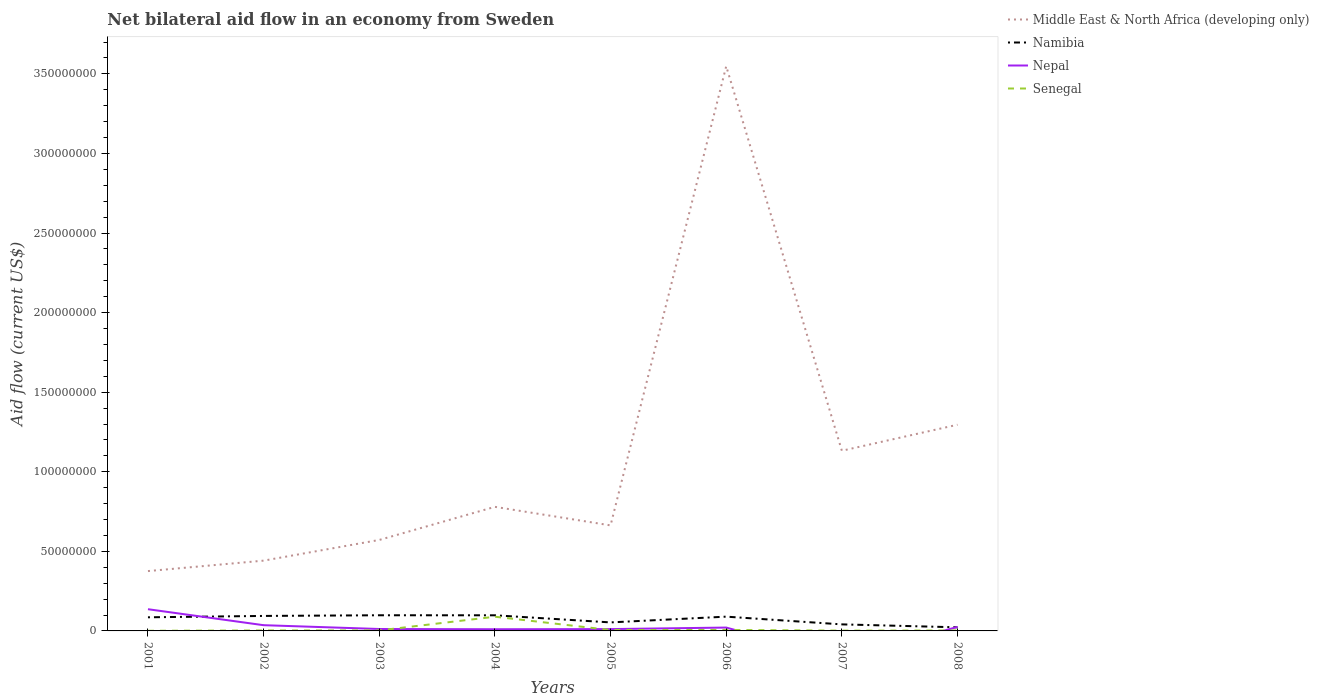How many different coloured lines are there?
Offer a very short reply. 4. Does the line corresponding to Senegal intersect with the line corresponding to Namibia?
Your response must be concise. No. Across all years, what is the maximum net bilateral aid flow in Namibia?
Offer a very short reply. 2.27e+06. What is the total net bilateral aid flow in Namibia in the graph?
Provide a short and direct response. 7.55e+06. What is the difference between the highest and the second highest net bilateral aid flow in Namibia?
Give a very brief answer. 7.57e+06. What is the difference between the highest and the lowest net bilateral aid flow in Middle East & North Africa (developing only)?
Provide a succinct answer. 3. How many years are there in the graph?
Your answer should be compact. 8. What is the difference between two consecutive major ticks on the Y-axis?
Your answer should be compact. 5.00e+07. Are the values on the major ticks of Y-axis written in scientific E-notation?
Your answer should be compact. No. Does the graph contain grids?
Provide a short and direct response. No. Where does the legend appear in the graph?
Give a very brief answer. Top right. How are the legend labels stacked?
Provide a succinct answer. Vertical. What is the title of the graph?
Ensure brevity in your answer.  Net bilateral aid flow in an economy from Sweden. Does "Sub-Saharan Africa (all income levels)" appear as one of the legend labels in the graph?
Your answer should be very brief. No. What is the label or title of the X-axis?
Your answer should be very brief. Years. What is the label or title of the Y-axis?
Offer a terse response. Aid flow (current US$). What is the Aid flow (current US$) of Middle East & North Africa (developing only) in 2001?
Offer a terse response. 3.76e+07. What is the Aid flow (current US$) of Namibia in 2001?
Your answer should be very brief. 8.56e+06. What is the Aid flow (current US$) of Nepal in 2001?
Your answer should be very brief. 1.36e+07. What is the Aid flow (current US$) of Middle East & North Africa (developing only) in 2002?
Offer a terse response. 4.42e+07. What is the Aid flow (current US$) in Namibia in 2002?
Make the answer very short. 9.42e+06. What is the Aid flow (current US$) in Nepal in 2002?
Your response must be concise. 3.60e+06. What is the Aid flow (current US$) of Middle East & North Africa (developing only) in 2003?
Provide a short and direct response. 5.72e+07. What is the Aid flow (current US$) of Namibia in 2003?
Your answer should be very brief. 9.84e+06. What is the Aid flow (current US$) in Nepal in 2003?
Your answer should be compact. 1.21e+06. What is the Aid flow (current US$) of Middle East & North Africa (developing only) in 2004?
Provide a short and direct response. 7.80e+07. What is the Aid flow (current US$) in Namibia in 2004?
Ensure brevity in your answer.  9.82e+06. What is the Aid flow (current US$) of Nepal in 2004?
Ensure brevity in your answer.  1.05e+06. What is the Aid flow (current US$) of Senegal in 2004?
Keep it short and to the point. 8.93e+06. What is the Aid flow (current US$) of Middle East & North Africa (developing only) in 2005?
Your answer should be compact. 6.63e+07. What is the Aid flow (current US$) of Namibia in 2005?
Offer a very short reply. 5.35e+06. What is the Aid flow (current US$) in Nepal in 2005?
Make the answer very short. 1.15e+06. What is the Aid flow (current US$) in Senegal in 2005?
Keep it short and to the point. 5.60e+05. What is the Aid flow (current US$) in Middle East & North Africa (developing only) in 2006?
Your answer should be very brief. 3.55e+08. What is the Aid flow (current US$) of Namibia in 2006?
Give a very brief answer. 8.97e+06. What is the Aid flow (current US$) of Nepal in 2006?
Provide a succinct answer. 2.11e+06. What is the Aid flow (current US$) of Senegal in 2006?
Provide a succinct answer. 6.20e+05. What is the Aid flow (current US$) in Middle East & North Africa (developing only) in 2007?
Provide a succinct answer. 1.13e+08. What is the Aid flow (current US$) in Namibia in 2007?
Give a very brief answer. 4.11e+06. What is the Aid flow (current US$) of Nepal in 2007?
Your response must be concise. 0. What is the Aid flow (current US$) in Senegal in 2007?
Offer a terse response. 1.90e+05. What is the Aid flow (current US$) in Middle East & North Africa (developing only) in 2008?
Your response must be concise. 1.30e+08. What is the Aid flow (current US$) in Namibia in 2008?
Make the answer very short. 2.27e+06. What is the Aid flow (current US$) of Nepal in 2008?
Your response must be concise. 2.53e+06. What is the Aid flow (current US$) in Senegal in 2008?
Your answer should be compact. 2.90e+05. Across all years, what is the maximum Aid flow (current US$) of Middle East & North Africa (developing only)?
Offer a very short reply. 3.55e+08. Across all years, what is the maximum Aid flow (current US$) of Namibia?
Provide a succinct answer. 9.84e+06. Across all years, what is the maximum Aid flow (current US$) in Nepal?
Give a very brief answer. 1.36e+07. Across all years, what is the maximum Aid flow (current US$) of Senegal?
Provide a short and direct response. 8.93e+06. Across all years, what is the minimum Aid flow (current US$) in Middle East & North Africa (developing only)?
Make the answer very short. 3.76e+07. Across all years, what is the minimum Aid flow (current US$) of Namibia?
Provide a succinct answer. 2.27e+06. Across all years, what is the minimum Aid flow (current US$) in Nepal?
Keep it short and to the point. 0. Across all years, what is the minimum Aid flow (current US$) in Senegal?
Offer a very short reply. 9.00e+04. What is the total Aid flow (current US$) in Middle East & North Africa (developing only) in the graph?
Ensure brevity in your answer.  8.81e+08. What is the total Aid flow (current US$) in Namibia in the graph?
Provide a succinct answer. 5.83e+07. What is the total Aid flow (current US$) in Nepal in the graph?
Provide a succinct answer. 2.53e+07. What is the total Aid flow (current US$) in Senegal in the graph?
Provide a short and direct response. 1.13e+07. What is the difference between the Aid flow (current US$) of Middle East & North Africa (developing only) in 2001 and that in 2002?
Your answer should be very brief. -6.56e+06. What is the difference between the Aid flow (current US$) in Namibia in 2001 and that in 2002?
Keep it short and to the point. -8.60e+05. What is the difference between the Aid flow (current US$) in Nepal in 2001 and that in 2002?
Give a very brief answer. 1.00e+07. What is the difference between the Aid flow (current US$) of Senegal in 2001 and that in 2002?
Keep it short and to the point. -2.00e+05. What is the difference between the Aid flow (current US$) in Middle East & North Africa (developing only) in 2001 and that in 2003?
Offer a very short reply. -1.96e+07. What is the difference between the Aid flow (current US$) in Namibia in 2001 and that in 2003?
Offer a terse response. -1.28e+06. What is the difference between the Aid flow (current US$) in Nepal in 2001 and that in 2003?
Ensure brevity in your answer.  1.24e+07. What is the difference between the Aid flow (current US$) of Senegal in 2001 and that in 2003?
Offer a very short reply. -2.20e+05. What is the difference between the Aid flow (current US$) of Middle East & North Africa (developing only) in 2001 and that in 2004?
Provide a short and direct response. -4.04e+07. What is the difference between the Aid flow (current US$) in Namibia in 2001 and that in 2004?
Keep it short and to the point. -1.26e+06. What is the difference between the Aid flow (current US$) of Nepal in 2001 and that in 2004?
Offer a very short reply. 1.26e+07. What is the difference between the Aid flow (current US$) in Senegal in 2001 and that in 2004?
Give a very brief answer. -8.84e+06. What is the difference between the Aid flow (current US$) in Middle East & North Africa (developing only) in 2001 and that in 2005?
Ensure brevity in your answer.  -2.87e+07. What is the difference between the Aid flow (current US$) in Namibia in 2001 and that in 2005?
Offer a terse response. 3.21e+06. What is the difference between the Aid flow (current US$) of Nepal in 2001 and that in 2005?
Your answer should be compact. 1.25e+07. What is the difference between the Aid flow (current US$) in Senegal in 2001 and that in 2005?
Offer a very short reply. -4.70e+05. What is the difference between the Aid flow (current US$) of Middle East & North Africa (developing only) in 2001 and that in 2006?
Make the answer very short. -3.17e+08. What is the difference between the Aid flow (current US$) of Namibia in 2001 and that in 2006?
Your response must be concise. -4.10e+05. What is the difference between the Aid flow (current US$) of Nepal in 2001 and that in 2006?
Offer a terse response. 1.15e+07. What is the difference between the Aid flow (current US$) of Senegal in 2001 and that in 2006?
Ensure brevity in your answer.  -5.30e+05. What is the difference between the Aid flow (current US$) of Middle East & North Africa (developing only) in 2001 and that in 2007?
Give a very brief answer. -7.56e+07. What is the difference between the Aid flow (current US$) in Namibia in 2001 and that in 2007?
Your answer should be compact. 4.45e+06. What is the difference between the Aid flow (current US$) of Senegal in 2001 and that in 2007?
Keep it short and to the point. -1.00e+05. What is the difference between the Aid flow (current US$) in Middle East & North Africa (developing only) in 2001 and that in 2008?
Ensure brevity in your answer.  -9.20e+07. What is the difference between the Aid flow (current US$) in Namibia in 2001 and that in 2008?
Your response must be concise. 6.29e+06. What is the difference between the Aid flow (current US$) in Nepal in 2001 and that in 2008?
Give a very brief answer. 1.11e+07. What is the difference between the Aid flow (current US$) in Senegal in 2001 and that in 2008?
Your answer should be compact. -2.00e+05. What is the difference between the Aid flow (current US$) of Middle East & North Africa (developing only) in 2002 and that in 2003?
Offer a very short reply. -1.30e+07. What is the difference between the Aid flow (current US$) in Namibia in 2002 and that in 2003?
Offer a terse response. -4.20e+05. What is the difference between the Aid flow (current US$) of Nepal in 2002 and that in 2003?
Keep it short and to the point. 2.39e+06. What is the difference between the Aid flow (current US$) in Senegal in 2002 and that in 2003?
Keep it short and to the point. -2.00e+04. What is the difference between the Aid flow (current US$) of Middle East & North Africa (developing only) in 2002 and that in 2004?
Your answer should be very brief. -3.38e+07. What is the difference between the Aid flow (current US$) of Namibia in 2002 and that in 2004?
Ensure brevity in your answer.  -4.00e+05. What is the difference between the Aid flow (current US$) in Nepal in 2002 and that in 2004?
Offer a terse response. 2.55e+06. What is the difference between the Aid flow (current US$) in Senegal in 2002 and that in 2004?
Provide a succinct answer. -8.64e+06. What is the difference between the Aid flow (current US$) in Middle East & North Africa (developing only) in 2002 and that in 2005?
Your answer should be compact. -2.22e+07. What is the difference between the Aid flow (current US$) of Namibia in 2002 and that in 2005?
Give a very brief answer. 4.07e+06. What is the difference between the Aid flow (current US$) of Nepal in 2002 and that in 2005?
Keep it short and to the point. 2.45e+06. What is the difference between the Aid flow (current US$) in Senegal in 2002 and that in 2005?
Offer a very short reply. -2.70e+05. What is the difference between the Aid flow (current US$) of Middle East & North Africa (developing only) in 2002 and that in 2006?
Offer a terse response. -3.11e+08. What is the difference between the Aid flow (current US$) of Nepal in 2002 and that in 2006?
Your answer should be very brief. 1.49e+06. What is the difference between the Aid flow (current US$) of Senegal in 2002 and that in 2006?
Keep it short and to the point. -3.30e+05. What is the difference between the Aid flow (current US$) in Middle East & North Africa (developing only) in 2002 and that in 2007?
Your response must be concise. -6.90e+07. What is the difference between the Aid flow (current US$) of Namibia in 2002 and that in 2007?
Ensure brevity in your answer.  5.31e+06. What is the difference between the Aid flow (current US$) in Middle East & North Africa (developing only) in 2002 and that in 2008?
Make the answer very short. -8.54e+07. What is the difference between the Aid flow (current US$) in Namibia in 2002 and that in 2008?
Keep it short and to the point. 7.15e+06. What is the difference between the Aid flow (current US$) in Nepal in 2002 and that in 2008?
Offer a terse response. 1.07e+06. What is the difference between the Aid flow (current US$) in Senegal in 2002 and that in 2008?
Provide a succinct answer. 0. What is the difference between the Aid flow (current US$) of Middle East & North Africa (developing only) in 2003 and that in 2004?
Provide a short and direct response. -2.08e+07. What is the difference between the Aid flow (current US$) of Senegal in 2003 and that in 2004?
Your response must be concise. -8.62e+06. What is the difference between the Aid flow (current US$) in Middle East & North Africa (developing only) in 2003 and that in 2005?
Your answer should be very brief. -9.15e+06. What is the difference between the Aid flow (current US$) of Namibia in 2003 and that in 2005?
Make the answer very short. 4.49e+06. What is the difference between the Aid flow (current US$) in Nepal in 2003 and that in 2005?
Your response must be concise. 6.00e+04. What is the difference between the Aid flow (current US$) of Middle East & North Africa (developing only) in 2003 and that in 2006?
Give a very brief answer. -2.98e+08. What is the difference between the Aid flow (current US$) of Namibia in 2003 and that in 2006?
Give a very brief answer. 8.70e+05. What is the difference between the Aid flow (current US$) of Nepal in 2003 and that in 2006?
Your answer should be very brief. -9.00e+05. What is the difference between the Aid flow (current US$) of Senegal in 2003 and that in 2006?
Offer a terse response. -3.10e+05. What is the difference between the Aid flow (current US$) in Middle East & North Africa (developing only) in 2003 and that in 2007?
Offer a very short reply. -5.60e+07. What is the difference between the Aid flow (current US$) of Namibia in 2003 and that in 2007?
Make the answer very short. 5.73e+06. What is the difference between the Aid flow (current US$) of Senegal in 2003 and that in 2007?
Offer a very short reply. 1.20e+05. What is the difference between the Aid flow (current US$) in Middle East & North Africa (developing only) in 2003 and that in 2008?
Provide a short and direct response. -7.24e+07. What is the difference between the Aid flow (current US$) in Namibia in 2003 and that in 2008?
Give a very brief answer. 7.57e+06. What is the difference between the Aid flow (current US$) of Nepal in 2003 and that in 2008?
Your answer should be compact. -1.32e+06. What is the difference between the Aid flow (current US$) of Middle East & North Africa (developing only) in 2004 and that in 2005?
Ensure brevity in your answer.  1.16e+07. What is the difference between the Aid flow (current US$) in Namibia in 2004 and that in 2005?
Give a very brief answer. 4.47e+06. What is the difference between the Aid flow (current US$) in Nepal in 2004 and that in 2005?
Your response must be concise. -1.00e+05. What is the difference between the Aid flow (current US$) of Senegal in 2004 and that in 2005?
Offer a terse response. 8.37e+06. What is the difference between the Aid flow (current US$) of Middle East & North Africa (developing only) in 2004 and that in 2006?
Your answer should be very brief. -2.77e+08. What is the difference between the Aid flow (current US$) of Namibia in 2004 and that in 2006?
Offer a very short reply. 8.50e+05. What is the difference between the Aid flow (current US$) of Nepal in 2004 and that in 2006?
Make the answer very short. -1.06e+06. What is the difference between the Aid flow (current US$) of Senegal in 2004 and that in 2006?
Ensure brevity in your answer.  8.31e+06. What is the difference between the Aid flow (current US$) of Middle East & North Africa (developing only) in 2004 and that in 2007?
Your response must be concise. -3.52e+07. What is the difference between the Aid flow (current US$) of Namibia in 2004 and that in 2007?
Offer a very short reply. 5.71e+06. What is the difference between the Aid flow (current US$) of Senegal in 2004 and that in 2007?
Make the answer very short. 8.74e+06. What is the difference between the Aid flow (current US$) of Middle East & North Africa (developing only) in 2004 and that in 2008?
Your answer should be compact. -5.16e+07. What is the difference between the Aid flow (current US$) in Namibia in 2004 and that in 2008?
Ensure brevity in your answer.  7.55e+06. What is the difference between the Aid flow (current US$) of Nepal in 2004 and that in 2008?
Your response must be concise. -1.48e+06. What is the difference between the Aid flow (current US$) of Senegal in 2004 and that in 2008?
Offer a very short reply. 8.64e+06. What is the difference between the Aid flow (current US$) in Middle East & North Africa (developing only) in 2005 and that in 2006?
Your response must be concise. -2.88e+08. What is the difference between the Aid flow (current US$) in Namibia in 2005 and that in 2006?
Your answer should be very brief. -3.62e+06. What is the difference between the Aid flow (current US$) in Nepal in 2005 and that in 2006?
Keep it short and to the point. -9.60e+05. What is the difference between the Aid flow (current US$) in Middle East & North Africa (developing only) in 2005 and that in 2007?
Your response must be concise. -4.69e+07. What is the difference between the Aid flow (current US$) in Namibia in 2005 and that in 2007?
Offer a very short reply. 1.24e+06. What is the difference between the Aid flow (current US$) in Senegal in 2005 and that in 2007?
Make the answer very short. 3.70e+05. What is the difference between the Aid flow (current US$) in Middle East & North Africa (developing only) in 2005 and that in 2008?
Keep it short and to the point. -6.32e+07. What is the difference between the Aid flow (current US$) of Namibia in 2005 and that in 2008?
Provide a short and direct response. 3.08e+06. What is the difference between the Aid flow (current US$) of Nepal in 2005 and that in 2008?
Provide a succinct answer. -1.38e+06. What is the difference between the Aid flow (current US$) of Middle East & North Africa (developing only) in 2006 and that in 2007?
Your response must be concise. 2.42e+08. What is the difference between the Aid flow (current US$) of Namibia in 2006 and that in 2007?
Keep it short and to the point. 4.86e+06. What is the difference between the Aid flow (current US$) in Senegal in 2006 and that in 2007?
Provide a succinct answer. 4.30e+05. What is the difference between the Aid flow (current US$) of Middle East & North Africa (developing only) in 2006 and that in 2008?
Provide a short and direct response. 2.25e+08. What is the difference between the Aid flow (current US$) in Namibia in 2006 and that in 2008?
Offer a very short reply. 6.70e+06. What is the difference between the Aid flow (current US$) of Nepal in 2006 and that in 2008?
Give a very brief answer. -4.20e+05. What is the difference between the Aid flow (current US$) of Middle East & North Africa (developing only) in 2007 and that in 2008?
Provide a succinct answer. -1.63e+07. What is the difference between the Aid flow (current US$) of Namibia in 2007 and that in 2008?
Offer a terse response. 1.84e+06. What is the difference between the Aid flow (current US$) of Senegal in 2007 and that in 2008?
Your answer should be very brief. -1.00e+05. What is the difference between the Aid flow (current US$) of Middle East & North Africa (developing only) in 2001 and the Aid flow (current US$) of Namibia in 2002?
Keep it short and to the point. 2.82e+07. What is the difference between the Aid flow (current US$) in Middle East & North Africa (developing only) in 2001 and the Aid flow (current US$) in Nepal in 2002?
Your answer should be compact. 3.40e+07. What is the difference between the Aid flow (current US$) of Middle East & North Africa (developing only) in 2001 and the Aid flow (current US$) of Senegal in 2002?
Your answer should be very brief. 3.73e+07. What is the difference between the Aid flow (current US$) in Namibia in 2001 and the Aid flow (current US$) in Nepal in 2002?
Offer a terse response. 4.96e+06. What is the difference between the Aid flow (current US$) in Namibia in 2001 and the Aid flow (current US$) in Senegal in 2002?
Your response must be concise. 8.27e+06. What is the difference between the Aid flow (current US$) in Nepal in 2001 and the Aid flow (current US$) in Senegal in 2002?
Your answer should be compact. 1.34e+07. What is the difference between the Aid flow (current US$) in Middle East & North Africa (developing only) in 2001 and the Aid flow (current US$) in Namibia in 2003?
Your answer should be very brief. 2.78e+07. What is the difference between the Aid flow (current US$) in Middle East & North Africa (developing only) in 2001 and the Aid flow (current US$) in Nepal in 2003?
Your answer should be very brief. 3.64e+07. What is the difference between the Aid flow (current US$) in Middle East & North Africa (developing only) in 2001 and the Aid flow (current US$) in Senegal in 2003?
Give a very brief answer. 3.73e+07. What is the difference between the Aid flow (current US$) in Namibia in 2001 and the Aid flow (current US$) in Nepal in 2003?
Your answer should be compact. 7.35e+06. What is the difference between the Aid flow (current US$) of Namibia in 2001 and the Aid flow (current US$) of Senegal in 2003?
Your answer should be compact. 8.25e+06. What is the difference between the Aid flow (current US$) in Nepal in 2001 and the Aid flow (current US$) in Senegal in 2003?
Provide a short and direct response. 1.33e+07. What is the difference between the Aid flow (current US$) in Middle East & North Africa (developing only) in 2001 and the Aid flow (current US$) in Namibia in 2004?
Give a very brief answer. 2.78e+07. What is the difference between the Aid flow (current US$) of Middle East & North Africa (developing only) in 2001 and the Aid flow (current US$) of Nepal in 2004?
Offer a terse response. 3.66e+07. What is the difference between the Aid flow (current US$) of Middle East & North Africa (developing only) in 2001 and the Aid flow (current US$) of Senegal in 2004?
Your response must be concise. 2.87e+07. What is the difference between the Aid flow (current US$) of Namibia in 2001 and the Aid flow (current US$) of Nepal in 2004?
Offer a terse response. 7.51e+06. What is the difference between the Aid flow (current US$) of Namibia in 2001 and the Aid flow (current US$) of Senegal in 2004?
Your answer should be compact. -3.70e+05. What is the difference between the Aid flow (current US$) of Nepal in 2001 and the Aid flow (current US$) of Senegal in 2004?
Keep it short and to the point. 4.71e+06. What is the difference between the Aid flow (current US$) in Middle East & North Africa (developing only) in 2001 and the Aid flow (current US$) in Namibia in 2005?
Provide a succinct answer. 3.22e+07. What is the difference between the Aid flow (current US$) in Middle East & North Africa (developing only) in 2001 and the Aid flow (current US$) in Nepal in 2005?
Offer a terse response. 3.64e+07. What is the difference between the Aid flow (current US$) of Middle East & North Africa (developing only) in 2001 and the Aid flow (current US$) of Senegal in 2005?
Offer a very short reply. 3.70e+07. What is the difference between the Aid flow (current US$) of Namibia in 2001 and the Aid flow (current US$) of Nepal in 2005?
Ensure brevity in your answer.  7.41e+06. What is the difference between the Aid flow (current US$) of Nepal in 2001 and the Aid flow (current US$) of Senegal in 2005?
Offer a terse response. 1.31e+07. What is the difference between the Aid flow (current US$) in Middle East & North Africa (developing only) in 2001 and the Aid flow (current US$) in Namibia in 2006?
Your answer should be compact. 2.86e+07. What is the difference between the Aid flow (current US$) in Middle East & North Africa (developing only) in 2001 and the Aid flow (current US$) in Nepal in 2006?
Keep it short and to the point. 3.55e+07. What is the difference between the Aid flow (current US$) of Middle East & North Africa (developing only) in 2001 and the Aid flow (current US$) of Senegal in 2006?
Keep it short and to the point. 3.70e+07. What is the difference between the Aid flow (current US$) of Namibia in 2001 and the Aid flow (current US$) of Nepal in 2006?
Provide a succinct answer. 6.45e+06. What is the difference between the Aid flow (current US$) of Namibia in 2001 and the Aid flow (current US$) of Senegal in 2006?
Your response must be concise. 7.94e+06. What is the difference between the Aid flow (current US$) in Nepal in 2001 and the Aid flow (current US$) in Senegal in 2006?
Keep it short and to the point. 1.30e+07. What is the difference between the Aid flow (current US$) of Middle East & North Africa (developing only) in 2001 and the Aid flow (current US$) of Namibia in 2007?
Keep it short and to the point. 3.35e+07. What is the difference between the Aid flow (current US$) of Middle East & North Africa (developing only) in 2001 and the Aid flow (current US$) of Senegal in 2007?
Offer a very short reply. 3.74e+07. What is the difference between the Aid flow (current US$) in Namibia in 2001 and the Aid flow (current US$) in Senegal in 2007?
Keep it short and to the point. 8.37e+06. What is the difference between the Aid flow (current US$) in Nepal in 2001 and the Aid flow (current US$) in Senegal in 2007?
Your response must be concise. 1.34e+07. What is the difference between the Aid flow (current US$) of Middle East & North Africa (developing only) in 2001 and the Aid flow (current US$) of Namibia in 2008?
Provide a short and direct response. 3.53e+07. What is the difference between the Aid flow (current US$) of Middle East & North Africa (developing only) in 2001 and the Aid flow (current US$) of Nepal in 2008?
Give a very brief answer. 3.51e+07. What is the difference between the Aid flow (current US$) in Middle East & North Africa (developing only) in 2001 and the Aid flow (current US$) in Senegal in 2008?
Provide a short and direct response. 3.73e+07. What is the difference between the Aid flow (current US$) in Namibia in 2001 and the Aid flow (current US$) in Nepal in 2008?
Ensure brevity in your answer.  6.03e+06. What is the difference between the Aid flow (current US$) of Namibia in 2001 and the Aid flow (current US$) of Senegal in 2008?
Your answer should be compact. 8.27e+06. What is the difference between the Aid flow (current US$) in Nepal in 2001 and the Aid flow (current US$) in Senegal in 2008?
Make the answer very short. 1.34e+07. What is the difference between the Aid flow (current US$) in Middle East & North Africa (developing only) in 2002 and the Aid flow (current US$) in Namibia in 2003?
Provide a succinct answer. 3.43e+07. What is the difference between the Aid flow (current US$) in Middle East & North Africa (developing only) in 2002 and the Aid flow (current US$) in Nepal in 2003?
Make the answer very short. 4.30e+07. What is the difference between the Aid flow (current US$) of Middle East & North Africa (developing only) in 2002 and the Aid flow (current US$) of Senegal in 2003?
Your response must be concise. 4.38e+07. What is the difference between the Aid flow (current US$) of Namibia in 2002 and the Aid flow (current US$) of Nepal in 2003?
Offer a terse response. 8.21e+06. What is the difference between the Aid flow (current US$) in Namibia in 2002 and the Aid flow (current US$) in Senegal in 2003?
Give a very brief answer. 9.11e+06. What is the difference between the Aid flow (current US$) in Nepal in 2002 and the Aid flow (current US$) in Senegal in 2003?
Offer a very short reply. 3.29e+06. What is the difference between the Aid flow (current US$) in Middle East & North Africa (developing only) in 2002 and the Aid flow (current US$) in Namibia in 2004?
Ensure brevity in your answer.  3.43e+07. What is the difference between the Aid flow (current US$) of Middle East & North Africa (developing only) in 2002 and the Aid flow (current US$) of Nepal in 2004?
Provide a succinct answer. 4.31e+07. What is the difference between the Aid flow (current US$) in Middle East & North Africa (developing only) in 2002 and the Aid flow (current US$) in Senegal in 2004?
Provide a succinct answer. 3.52e+07. What is the difference between the Aid flow (current US$) of Namibia in 2002 and the Aid flow (current US$) of Nepal in 2004?
Ensure brevity in your answer.  8.37e+06. What is the difference between the Aid flow (current US$) of Namibia in 2002 and the Aid flow (current US$) of Senegal in 2004?
Your answer should be compact. 4.90e+05. What is the difference between the Aid flow (current US$) of Nepal in 2002 and the Aid flow (current US$) of Senegal in 2004?
Keep it short and to the point. -5.33e+06. What is the difference between the Aid flow (current US$) of Middle East & North Africa (developing only) in 2002 and the Aid flow (current US$) of Namibia in 2005?
Ensure brevity in your answer.  3.88e+07. What is the difference between the Aid flow (current US$) of Middle East & North Africa (developing only) in 2002 and the Aid flow (current US$) of Nepal in 2005?
Your answer should be very brief. 4.30e+07. What is the difference between the Aid flow (current US$) of Middle East & North Africa (developing only) in 2002 and the Aid flow (current US$) of Senegal in 2005?
Give a very brief answer. 4.36e+07. What is the difference between the Aid flow (current US$) of Namibia in 2002 and the Aid flow (current US$) of Nepal in 2005?
Offer a terse response. 8.27e+06. What is the difference between the Aid flow (current US$) of Namibia in 2002 and the Aid flow (current US$) of Senegal in 2005?
Keep it short and to the point. 8.86e+06. What is the difference between the Aid flow (current US$) in Nepal in 2002 and the Aid flow (current US$) in Senegal in 2005?
Your answer should be very brief. 3.04e+06. What is the difference between the Aid flow (current US$) in Middle East & North Africa (developing only) in 2002 and the Aid flow (current US$) in Namibia in 2006?
Make the answer very short. 3.52e+07. What is the difference between the Aid flow (current US$) of Middle East & North Africa (developing only) in 2002 and the Aid flow (current US$) of Nepal in 2006?
Your answer should be compact. 4.20e+07. What is the difference between the Aid flow (current US$) of Middle East & North Africa (developing only) in 2002 and the Aid flow (current US$) of Senegal in 2006?
Your response must be concise. 4.35e+07. What is the difference between the Aid flow (current US$) in Namibia in 2002 and the Aid flow (current US$) in Nepal in 2006?
Keep it short and to the point. 7.31e+06. What is the difference between the Aid flow (current US$) of Namibia in 2002 and the Aid flow (current US$) of Senegal in 2006?
Keep it short and to the point. 8.80e+06. What is the difference between the Aid flow (current US$) of Nepal in 2002 and the Aid flow (current US$) of Senegal in 2006?
Offer a very short reply. 2.98e+06. What is the difference between the Aid flow (current US$) in Middle East & North Africa (developing only) in 2002 and the Aid flow (current US$) in Namibia in 2007?
Make the answer very short. 4.00e+07. What is the difference between the Aid flow (current US$) of Middle East & North Africa (developing only) in 2002 and the Aid flow (current US$) of Senegal in 2007?
Ensure brevity in your answer.  4.40e+07. What is the difference between the Aid flow (current US$) in Namibia in 2002 and the Aid flow (current US$) in Senegal in 2007?
Your answer should be compact. 9.23e+06. What is the difference between the Aid flow (current US$) in Nepal in 2002 and the Aid flow (current US$) in Senegal in 2007?
Provide a short and direct response. 3.41e+06. What is the difference between the Aid flow (current US$) in Middle East & North Africa (developing only) in 2002 and the Aid flow (current US$) in Namibia in 2008?
Your answer should be very brief. 4.19e+07. What is the difference between the Aid flow (current US$) in Middle East & North Africa (developing only) in 2002 and the Aid flow (current US$) in Nepal in 2008?
Keep it short and to the point. 4.16e+07. What is the difference between the Aid flow (current US$) in Middle East & North Africa (developing only) in 2002 and the Aid flow (current US$) in Senegal in 2008?
Keep it short and to the point. 4.39e+07. What is the difference between the Aid flow (current US$) of Namibia in 2002 and the Aid flow (current US$) of Nepal in 2008?
Provide a succinct answer. 6.89e+06. What is the difference between the Aid flow (current US$) of Namibia in 2002 and the Aid flow (current US$) of Senegal in 2008?
Provide a short and direct response. 9.13e+06. What is the difference between the Aid flow (current US$) of Nepal in 2002 and the Aid flow (current US$) of Senegal in 2008?
Your response must be concise. 3.31e+06. What is the difference between the Aid flow (current US$) of Middle East & North Africa (developing only) in 2003 and the Aid flow (current US$) of Namibia in 2004?
Keep it short and to the point. 4.73e+07. What is the difference between the Aid flow (current US$) in Middle East & North Africa (developing only) in 2003 and the Aid flow (current US$) in Nepal in 2004?
Ensure brevity in your answer.  5.61e+07. What is the difference between the Aid flow (current US$) in Middle East & North Africa (developing only) in 2003 and the Aid flow (current US$) in Senegal in 2004?
Keep it short and to the point. 4.82e+07. What is the difference between the Aid flow (current US$) of Namibia in 2003 and the Aid flow (current US$) of Nepal in 2004?
Provide a succinct answer. 8.79e+06. What is the difference between the Aid flow (current US$) of Namibia in 2003 and the Aid flow (current US$) of Senegal in 2004?
Offer a terse response. 9.10e+05. What is the difference between the Aid flow (current US$) of Nepal in 2003 and the Aid flow (current US$) of Senegal in 2004?
Provide a succinct answer. -7.72e+06. What is the difference between the Aid flow (current US$) of Middle East & North Africa (developing only) in 2003 and the Aid flow (current US$) of Namibia in 2005?
Your response must be concise. 5.18e+07. What is the difference between the Aid flow (current US$) in Middle East & North Africa (developing only) in 2003 and the Aid flow (current US$) in Nepal in 2005?
Your response must be concise. 5.60e+07. What is the difference between the Aid flow (current US$) of Middle East & North Africa (developing only) in 2003 and the Aid flow (current US$) of Senegal in 2005?
Your answer should be very brief. 5.66e+07. What is the difference between the Aid flow (current US$) of Namibia in 2003 and the Aid flow (current US$) of Nepal in 2005?
Your answer should be compact. 8.69e+06. What is the difference between the Aid flow (current US$) in Namibia in 2003 and the Aid flow (current US$) in Senegal in 2005?
Provide a short and direct response. 9.28e+06. What is the difference between the Aid flow (current US$) in Nepal in 2003 and the Aid flow (current US$) in Senegal in 2005?
Provide a short and direct response. 6.50e+05. What is the difference between the Aid flow (current US$) in Middle East & North Africa (developing only) in 2003 and the Aid flow (current US$) in Namibia in 2006?
Provide a short and direct response. 4.82e+07. What is the difference between the Aid flow (current US$) in Middle East & North Africa (developing only) in 2003 and the Aid flow (current US$) in Nepal in 2006?
Ensure brevity in your answer.  5.50e+07. What is the difference between the Aid flow (current US$) in Middle East & North Africa (developing only) in 2003 and the Aid flow (current US$) in Senegal in 2006?
Your answer should be very brief. 5.65e+07. What is the difference between the Aid flow (current US$) in Namibia in 2003 and the Aid flow (current US$) in Nepal in 2006?
Your answer should be compact. 7.73e+06. What is the difference between the Aid flow (current US$) in Namibia in 2003 and the Aid flow (current US$) in Senegal in 2006?
Your response must be concise. 9.22e+06. What is the difference between the Aid flow (current US$) in Nepal in 2003 and the Aid flow (current US$) in Senegal in 2006?
Make the answer very short. 5.90e+05. What is the difference between the Aid flow (current US$) in Middle East & North Africa (developing only) in 2003 and the Aid flow (current US$) in Namibia in 2007?
Your response must be concise. 5.30e+07. What is the difference between the Aid flow (current US$) of Middle East & North Africa (developing only) in 2003 and the Aid flow (current US$) of Senegal in 2007?
Your answer should be compact. 5.70e+07. What is the difference between the Aid flow (current US$) in Namibia in 2003 and the Aid flow (current US$) in Senegal in 2007?
Offer a terse response. 9.65e+06. What is the difference between the Aid flow (current US$) of Nepal in 2003 and the Aid flow (current US$) of Senegal in 2007?
Give a very brief answer. 1.02e+06. What is the difference between the Aid flow (current US$) of Middle East & North Africa (developing only) in 2003 and the Aid flow (current US$) of Namibia in 2008?
Provide a succinct answer. 5.49e+07. What is the difference between the Aid flow (current US$) of Middle East & North Africa (developing only) in 2003 and the Aid flow (current US$) of Nepal in 2008?
Make the answer very short. 5.46e+07. What is the difference between the Aid flow (current US$) in Middle East & North Africa (developing only) in 2003 and the Aid flow (current US$) in Senegal in 2008?
Ensure brevity in your answer.  5.69e+07. What is the difference between the Aid flow (current US$) in Namibia in 2003 and the Aid flow (current US$) in Nepal in 2008?
Keep it short and to the point. 7.31e+06. What is the difference between the Aid flow (current US$) of Namibia in 2003 and the Aid flow (current US$) of Senegal in 2008?
Your answer should be compact. 9.55e+06. What is the difference between the Aid flow (current US$) in Nepal in 2003 and the Aid flow (current US$) in Senegal in 2008?
Ensure brevity in your answer.  9.20e+05. What is the difference between the Aid flow (current US$) of Middle East & North Africa (developing only) in 2004 and the Aid flow (current US$) of Namibia in 2005?
Provide a succinct answer. 7.26e+07. What is the difference between the Aid flow (current US$) of Middle East & North Africa (developing only) in 2004 and the Aid flow (current US$) of Nepal in 2005?
Your response must be concise. 7.68e+07. What is the difference between the Aid flow (current US$) of Middle East & North Africa (developing only) in 2004 and the Aid flow (current US$) of Senegal in 2005?
Offer a terse response. 7.74e+07. What is the difference between the Aid flow (current US$) in Namibia in 2004 and the Aid flow (current US$) in Nepal in 2005?
Offer a very short reply. 8.67e+06. What is the difference between the Aid flow (current US$) of Namibia in 2004 and the Aid flow (current US$) of Senegal in 2005?
Offer a very short reply. 9.26e+06. What is the difference between the Aid flow (current US$) of Nepal in 2004 and the Aid flow (current US$) of Senegal in 2005?
Ensure brevity in your answer.  4.90e+05. What is the difference between the Aid flow (current US$) in Middle East & North Africa (developing only) in 2004 and the Aid flow (current US$) in Namibia in 2006?
Provide a short and direct response. 6.90e+07. What is the difference between the Aid flow (current US$) in Middle East & North Africa (developing only) in 2004 and the Aid flow (current US$) in Nepal in 2006?
Offer a very short reply. 7.58e+07. What is the difference between the Aid flow (current US$) in Middle East & North Africa (developing only) in 2004 and the Aid flow (current US$) in Senegal in 2006?
Offer a very short reply. 7.73e+07. What is the difference between the Aid flow (current US$) in Namibia in 2004 and the Aid flow (current US$) in Nepal in 2006?
Keep it short and to the point. 7.71e+06. What is the difference between the Aid flow (current US$) of Namibia in 2004 and the Aid flow (current US$) of Senegal in 2006?
Your answer should be very brief. 9.20e+06. What is the difference between the Aid flow (current US$) of Nepal in 2004 and the Aid flow (current US$) of Senegal in 2006?
Provide a succinct answer. 4.30e+05. What is the difference between the Aid flow (current US$) of Middle East & North Africa (developing only) in 2004 and the Aid flow (current US$) of Namibia in 2007?
Provide a short and direct response. 7.38e+07. What is the difference between the Aid flow (current US$) in Middle East & North Africa (developing only) in 2004 and the Aid flow (current US$) in Senegal in 2007?
Provide a succinct answer. 7.78e+07. What is the difference between the Aid flow (current US$) of Namibia in 2004 and the Aid flow (current US$) of Senegal in 2007?
Your answer should be very brief. 9.63e+06. What is the difference between the Aid flow (current US$) in Nepal in 2004 and the Aid flow (current US$) in Senegal in 2007?
Give a very brief answer. 8.60e+05. What is the difference between the Aid flow (current US$) of Middle East & North Africa (developing only) in 2004 and the Aid flow (current US$) of Namibia in 2008?
Provide a short and direct response. 7.57e+07. What is the difference between the Aid flow (current US$) of Middle East & North Africa (developing only) in 2004 and the Aid flow (current US$) of Nepal in 2008?
Offer a very short reply. 7.54e+07. What is the difference between the Aid flow (current US$) in Middle East & North Africa (developing only) in 2004 and the Aid flow (current US$) in Senegal in 2008?
Give a very brief answer. 7.77e+07. What is the difference between the Aid flow (current US$) of Namibia in 2004 and the Aid flow (current US$) of Nepal in 2008?
Give a very brief answer. 7.29e+06. What is the difference between the Aid flow (current US$) in Namibia in 2004 and the Aid flow (current US$) in Senegal in 2008?
Your response must be concise. 9.53e+06. What is the difference between the Aid flow (current US$) of Nepal in 2004 and the Aid flow (current US$) of Senegal in 2008?
Your answer should be very brief. 7.60e+05. What is the difference between the Aid flow (current US$) in Middle East & North Africa (developing only) in 2005 and the Aid flow (current US$) in Namibia in 2006?
Your response must be concise. 5.73e+07. What is the difference between the Aid flow (current US$) in Middle East & North Africa (developing only) in 2005 and the Aid flow (current US$) in Nepal in 2006?
Keep it short and to the point. 6.42e+07. What is the difference between the Aid flow (current US$) of Middle East & North Africa (developing only) in 2005 and the Aid flow (current US$) of Senegal in 2006?
Give a very brief answer. 6.57e+07. What is the difference between the Aid flow (current US$) of Namibia in 2005 and the Aid flow (current US$) of Nepal in 2006?
Give a very brief answer. 3.24e+06. What is the difference between the Aid flow (current US$) in Namibia in 2005 and the Aid flow (current US$) in Senegal in 2006?
Your answer should be very brief. 4.73e+06. What is the difference between the Aid flow (current US$) in Nepal in 2005 and the Aid flow (current US$) in Senegal in 2006?
Make the answer very short. 5.30e+05. What is the difference between the Aid flow (current US$) in Middle East & North Africa (developing only) in 2005 and the Aid flow (current US$) in Namibia in 2007?
Offer a terse response. 6.22e+07. What is the difference between the Aid flow (current US$) of Middle East & North Africa (developing only) in 2005 and the Aid flow (current US$) of Senegal in 2007?
Your answer should be very brief. 6.61e+07. What is the difference between the Aid flow (current US$) in Namibia in 2005 and the Aid flow (current US$) in Senegal in 2007?
Give a very brief answer. 5.16e+06. What is the difference between the Aid flow (current US$) of Nepal in 2005 and the Aid flow (current US$) of Senegal in 2007?
Your response must be concise. 9.60e+05. What is the difference between the Aid flow (current US$) in Middle East & North Africa (developing only) in 2005 and the Aid flow (current US$) in Namibia in 2008?
Provide a succinct answer. 6.40e+07. What is the difference between the Aid flow (current US$) of Middle East & North Africa (developing only) in 2005 and the Aid flow (current US$) of Nepal in 2008?
Ensure brevity in your answer.  6.38e+07. What is the difference between the Aid flow (current US$) in Middle East & North Africa (developing only) in 2005 and the Aid flow (current US$) in Senegal in 2008?
Offer a very short reply. 6.60e+07. What is the difference between the Aid flow (current US$) of Namibia in 2005 and the Aid flow (current US$) of Nepal in 2008?
Offer a terse response. 2.82e+06. What is the difference between the Aid flow (current US$) in Namibia in 2005 and the Aid flow (current US$) in Senegal in 2008?
Provide a succinct answer. 5.06e+06. What is the difference between the Aid flow (current US$) of Nepal in 2005 and the Aid flow (current US$) of Senegal in 2008?
Ensure brevity in your answer.  8.60e+05. What is the difference between the Aid flow (current US$) in Middle East & North Africa (developing only) in 2006 and the Aid flow (current US$) in Namibia in 2007?
Make the answer very short. 3.51e+08. What is the difference between the Aid flow (current US$) of Middle East & North Africa (developing only) in 2006 and the Aid flow (current US$) of Senegal in 2007?
Keep it short and to the point. 3.55e+08. What is the difference between the Aid flow (current US$) in Namibia in 2006 and the Aid flow (current US$) in Senegal in 2007?
Provide a short and direct response. 8.78e+06. What is the difference between the Aid flow (current US$) in Nepal in 2006 and the Aid flow (current US$) in Senegal in 2007?
Your response must be concise. 1.92e+06. What is the difference between the Aid flow (current US$) in Middle East & North Africa (developing only) in 2006 and the Aid flow (current US$) in Namibia in 2008?
Keep it short and to the point. 3.53e+08. What is the difference between the Aid flow (current US$) in Middle East & North Africa (developing only) in 2006 and the Aid flow (current US$) in Nepal in 2008?
Make the answer very short. 3.52e+08. What is the difference between the Aid flow (current US$) in Middle East & North Africa (developing only) in 2006 and the Aid flow (current US$) in Senegal in 2008?
Keep it short and to the point. 3.55e+08. What is the difference between the Aid flow (current US$) of Namibia in 2006 and the Aid flow (current US$) of Nepal in 2008?
Offer a terse response. 6.44e+06. What is the difference between the Aid flow (current US$) in Namibia in 2006 and the Aid flow (current US$) in Senegal in 2008?
Provide a short and direct response. 8.68e+06. What is the difference between the Aid flow (current US$) in Nepal in 2006 and the Aid flow (current US$) in Senegal in 2008?
Your response must be concise. 1.82e+06. What is the difference between the Aid flow (current US$) of Middle East & North Africa (developing only) in 2007 and the Aid flow (current US$) of Namibia in 2008?
Give a very brief answer. 1.11e+08. What is the difference between the Aid flow (current US$) of Middle East & North Africa (developing only) in 2007 and the Aid flow (current US$) of Nepal in 2008?
Your answer should be very brief. 1.11e+08. What is the difference between the Aid flow (current US$) in Middle East & North Africa (developing only) in 2007 and the Aid flow (current US$) in Senegal in 2008?
Your answer should be compact. 1.13e+08. What is the difference between the Aid flow (current US$) in Namibia in 2007 and the Aid flow (current US$) in Nepal in 2008?
Provide a short and direct response. 1.58e+06. What is the difference between the Aid flow (current US$) in Namibia in 2007 and the Aid flow (current US$) in Senegal in 2008?
Keep it short and to the point. 3.82e+06. What is the average Aid flow (current US$) in Middle East & North Africa (developing only) per year?
Ensure brevity in your answer.  1.10e+08. What is the average Aid flow (current US$) in Namibia per year?
Your response must be concise. 7.29e+06. What is the average Aid flow (current US$) of Nepal per year?
Offer a very short reply. 3.16e+06. What is the average Aid flow (current US$) in Senegal per year?
Ensure brevity in your answer.  1.41e+06. In the year 2001, what is the difference between the Aid flow (current US$) of Middle East & North Africa (developing only) and Aid flow (current US$) of Namibia?
Provide a succinct answer. 2.90e+07. In the year 2001, what is the difference between the Aid flow (current US$) in Middle East & North Africa (developing only) and Aid flow (current US$) in Nepal?
Your answer should be compact. 2.40e+07. In the year 2001, what is the difference between the Aid flow (current US$) of Middle East & North Africa (developing only) and Aid flow (current US$) of Senegal?
Keep it short and to the point. 3.75e+07. In the year 2001, what is the difference between the Aid flow (current US$) of Namibia and Aid flow (current US$) of Nepal?
Ensure brevity in your answer.  -5.08e+06. In the year 2001, what is the difference between the Aid flow (current US$) of Namibia and Aid flow (current US$) of Senegal?
Offer a very short reply. 8.47e+06. In the year 2001, what is the difference between the Aid flow (current US$) of Nepal and Aid flow (current US$) of Senegal?
Your response must be concise. 1.36e+07. In the year 2002, what is the difference between the Aid flow (current US$) of Middle East & North Africa (developing only) and Aid flow (current US$) of Namibia?
Make the answer very short. 3.47e+07. In the year 2002, what is the difference between the Aid flow (current US$) of Middle East & North Africa (developing only) and Aid flow (current US$) of Nepal?
Provide a succinct answer. 4.06e+07. In the year 2002, what is the difference between the Aid flow (current US$) of Middle East & North Africa (developing only) and Aid flow (current US$) of Senegal?
Ensure brevity in your answer.  4.39e+07. In the year 2002, what is the difference between the Aid flow (current US$) in Namibia and Aid flow (current US$) in Nepal?
Provide a short and direct response. 5.82e+06. In the year 2002, what is the difference between the Aid flow (current US$) in Namibia and Aid flow (current US$) in Senegal?
Offer a terse response. 9.13e+06. In the year 2002, what is the difference between the Aid flow (current US$) in Nepal and Aid flow (current US$) in Senegal?
Keep it short and to the point. 3.31e+06. In the year 2003, what is the difference between the Aid flow (current US$) in Middle East & North Africa (developing only) and Aid flow (current US$) in Namibia?
Your response must be concise. 4.73e+07. In the year 2003, what is the difference between the Aid flow (current US$) of Middle East & North Africa (developing only) and Aid flow (current US$) of Nepal?
Provide a short and direct response. 5.60e+07. In the year 2003, what is the difference between the Aid flow (current US$) of Middle East & North Africa (developing only) and Aid flow (current US$) of Senegal?
Offer a very short reply. 5.68e+07. In the year 2003, what is the difference between the Aid flow (current US$) in Namibia and Aid flow (current US$) in Nepal?
Your answer should be very brief. 8.63e+06. In the year 2003, what is the difference between the Aid flow (current US$) in Namibia and Aid flow (current US$) in Senegal?
Keep it short and to the point. 9.53e+06. In the year 2004, what is the difference between the Aid flow (current US$) of Middle East & North Africa (developing only) and Aid flow (current US$) of Namibia?
Ensure brevity in your answer.  6.81e+07. In the year 2004, what is the difference between the Aid flow (current US$) of Middle East & North Africa (developing only) and Aid flow (current US$) of Nepal?
Ensure brevity in your answer.  7.69e+07. In the year 2004, what is the difference between the Aid flow (current US$) in Middle East & North Africa (developing only) and Aid flow (current US$) in Senegal?
Give a very brief answer. 6.90e+07. In the year 2004, what is the difference between the Aid flow (current US$) in Namibia and Aid flow (current US$) in Nepal?
Offer a very short reply. 8.77e+06. In the year 2004, what is the difference between the Aid flow (current US$) of Namibia and Aid flow (current US$) of Senegal?
Give a very brief answer. 8.90e+05. In the year 2004, what is the difference between the Aid flow (current US$) in Nepal and Aid flow (current US$) in Senegal?
Your answer should be compact. -7.88e+06. In the year 2005, what is the difference between the Aid flow (current US$) in Middle East & North Africa (developing only) and Aid flow (current US$) in Namibia?
Make the answer very short. 6.10e+07. In the year 2005, what is the difference between the Aid flow (current US$) of Middle East & North Africa (developing only) and Aid flow (current US$) of Nepal?
Keep it short and to the point. 6.52e+07. In the year 2005, what is the difference between the Aid flow (current US$) in Middle East & North Africa (developing only) and Aid flow (current US$) in Senegal?
Make the answer very short. 6.58e+07. In the year 2005, what is the difference between the Aid flow (current US$) of Namibia and Aid flow (current US$) of Nepal?
Ensure brevity in your answer.  4.20e+06. In the year 2005, what is the difference between the Aid flow (current US$) of Namibia and Aid flow (current US$) of Senegal?
Your answer should be very brief. 4.79e+06. In the year 2005, what is the difference between the Aid flow (current US$) of Nepal and Aid flow (current US$) of Senegal?
Provide a succinct answer. 5.90e+05. In the year 2006, what is the difference between the Aid flow (current US$) of Middle East & North Africa (developing only) and Aid flow (current US$) of Namibia?
Provide a succinct answer. 3.46e+08. In the year 2006, what is the difference between the Aid flow (current US$) in Middle East & North Africa (developing only) and Aid flow (current US$) in Nepal?
Provide a short and direct response. 3.53e+08. In the year 2006, what is the difference between the Aid flow (current US$) of Middle East & North Africa (developing only) and Aid flow (current US$) of Senegal?
Provide a short and direct response. 3.54e+08. In the year 2006, what is the difference between the Aid flow (current US$) in Namibia and Aid flow (current US$) in Nepal?
Your response must be concise. 6.86e+06. In the year 2006, what is the difference between the Aid flow (current US$) of Namibia and Aid flow (current US$) of Senegal?
Make the answer very short. 8.35e+06. In the year 2006, what is the difference between the Aid flow (current US$) of Nepal and Aid flow (current US$) of Senegal?
Offer a very short reply. 1.49e+06. In the year 2007, what is the difference between the Aid flow (current US$) in Middle East & North Africa (developing only) and Aid flow (current US$) in Namibia?
Offer a terse response. 1.09e+08. In the year 2007, what is the difference between the Aid flow (current US$) in Middle East & North Africa (developing only) and Aid flow (current US$) in Senegal?
Your answer should be compact. 1.13e+08. In the year 2007, what is the difference between the Aid flow (current US$) in Namibia and Aid flow (current US$) in Senegal?
Provide a succinct answer. 3.92e+06. In the year 2008, what is the difference between the Aid flow (current US$) of Middle East & North Africa (developing only) and Aid flow (current US$) of Namibia?
Offer a very short reply. 1.27e+08. In the year 2008, what is the difference between the Aid flow (current US$) in Middle East & North Africa (developing only) and Aid flow (current US$) in Nepal?
Ensure brevity in your answer.  1.27e+08. In the year 2008, what is the difference between the Aid flow (current US$) in Middle East & North Africa (developing only) and Aid flow (current US$) in Senegal?
Your answer should be very brief. 1.29e+08. In the year 2008, what is the difference between the Aid flow (current US$) of Namibia and Aid flow (current US$) of Senegal?
Keep it short and to the point. 1.98e+06. In the year 2008, what is the difference between the Aid flow (current US$) of Nepal and Aid flow (current US$) of Senegal?
Your response must be concise. 2.24e+06. What is the ratio of the Aid flow (current US$) of Middle East & North Africa (developing only) in 2001 to that in 2002?
Your answer should be very brief. 0.85. What is the ratio of the Aid flow (current US$) in Namibia in 2001 to that in 2002?
Your answer should be compact. 0.91. What is the ratio of the Aid flow (current US$) of Nepal in 2001 to that in 2002?
Make the answer very short. 3.79. What is the ratio of the Aid flow (current US$) in Senegal in 2001 to that in 2002?
Provide a short and direct response. 0.31. What is the ratio of the Aid flow (current US$) of Middle East & North Africa (developing only) in 2001 to that in 2003?
Ensure brevity in your answer.  0.66. What is the ratio of the Aid flow (current US$) in Namibia in 2001 to that in 2003?
Give a very brief answer. 0.87. What is the ratio of the Aid flow (current US$) in Nepal in 2001 to that in 2003?
Your answer should be compact. 11.27. What is the ratio of the Aid flow (current US$) in Senegal in 2001 to that in 2003?
Make the answer very short. 0.29. What is the ratio of the Aid flow (current US$) in Middle East & North Africa (developing only) in 2001 to that in 2004?
Your response must be concise. 0.48. What is the ratio of the Aid flow (current US$) in Namibia in 2001 to that in 2004?
Your answer should be compact. 0.87. What is the ratio of the Aid flow (current US$) in Nepal in 2001 to that in 2004?
Provide a short and direct response. 12.99. What is the ratio of the Aid flow (current US$) of Senegal in 2001 to that in 2004?
Make the answer very short. 0.01. What is the ratio of the Aid flow (current US$) of Middle East & North Africa (developing only) in 2001 to that in 2005?
Your response must be concise. 0.57. What is the ratio of the Aid flow (current US$) of Namibia in 2001 to that in 2005?
Give a very brief answer. 1.6. What is the ratio of the Aid flow (current US$) in Nepal in 2001 to that in 2005?
Your response must be concise. 11.86. What is the ratio of the Aid flow (current US$) of Senegal in 2001 to that in 2005?
Your response must be concise. 0.16. What is the ratio of the Aid flow (current US$) of Middle East & North Africa (developing only) in 2001 to that in 2006?
Keep it short and to the point. 0.11. What is the ratio of the Aid flow (current US$) in Namibia in 2001 to that in 2006?
Give a very brief answer. 0.95. What is the ratio of the Aid flow (current US$) in Nepal in 2001 to that in 2006?
Your answer should be compact. 6.46. What is the ratio of the Aid flow (current US$) in Senegal in 2001 to that in 2006?
Give a very brief answer. 0.15. What is the ratio of the Aid flow (current US$) in Middle East & North Africa (developing only) in 2001 to that in 2007?
Offer a very short reply. 0.33. What is the ratio of the Aid flow (current US$) in Namibia in 2001 to that in 2007?
Your response must be concise. 2.08. What is the ratio of the Aid flow (current US$) of Senegal in 2001 to that in 2007?
Your answer should be compact. 0.47. What is the ratio of the Aid flow (current US$) of Middle East & North Africa (developing only) in 2001 to that in 2008?
Provide a succinct answer. 0.29. What is the ratio of the Aid flow (current US$) in Namibia in 2001 to that in 2008?
Offer a very short reply. 3.77. What is the ratio of the Aid flow (current US$) in Nepal in 2001 to that in 2008?
Your answer should be very brief. 5.39. What is the ratio of the Aid flow (current US$) of Senegal in 2001 to that in 2008?
Offer a terse response. 0.31. What is the ratio of the Aid flow (current US$) in Middle East & North Africa (developing only) in 2002 to that in 2003?
Keep it short and to the point. 0.77. What is the ratio of the Aid flow (current US$) of Namibia in 2002 to that in 2003?
Keep it short and to the point. 0.96. What is the ratio of the Aid flow (current US$) in Nepal in 2002 to that in 2003?
Your response must be concise. 2.98. What is the ratio of the Aid flow (current US$) in Senegal in 2002 to that in 2003?
Your answer should be compact. 0.94. What is the ratio of the Aid flow (current US$) in Middle East & North Africa (developing only) in 2002 to that in 2004?
Ensure brevity in your answer.  0.57. What is the ratio of the Aid flow (current US$) in Namibia in 2002 to that in 2004?
Provide a succinct answer. 0.96. What is the ratio of the Aid flow (current US$) of Nepal in 2002 to that in 2004?
Offer a very short reply. 3.43. What is the ratio of the Aid flow (current US$) in Senegal in 2002 to that in 2004?
Your response must be concise. 0.03. What is the ratio of the Aid flow (current US$) of Middle East & North Africa (developing only) in 2002 to that in 2005?
Your answer should be very brief. 0.67. What is the ratio of the Aid flow (current US$) in Namibia in 2002 to that in 2005?
Your response must be concise. 1.76. What is the ratio of the Aid flow (current US$) in Nepal in 2002 to that in 2005?
Your response must be concise. 3.13. What is the ratio of the Aid flow (current US$) in Senegal in 2002 to that in 2005?
Offer a terse response. 0.52. What is the ratio of the Aid flow (current US$) of Middle East & North Africa (developing only) in 2002 to that in 2006?
Ensure brevity in your answer.  0.12. What is the ratio of the Aid flow (current US$) of Namibia in 2002 to that in 2006?
Give a very brief answer. 1.05. What is the ratio of the Aid flow (current US$) in Nepal in 2002 to that in 2006?
Give a very brief answer. 1.71. What is the ratio of the Aid flow (current US$) of Senegal in 2002 to that in 2006?
Your answer should be very brief. 0.47. What is the ratio of the Aid flow (current US$) in Middle East & North Africa (developing only) in 2002 to that in 2007?
Offer a very short reply. 0.39. What is the ratio of the Aid flow (current US$) of Namibia in 2002 to that in 2007?
Your answer should be very brief. 2.29. What is the ratio of the Aid flow (current US$) in Senegal in 2002 to that in 2007?
Keep it short and to the point. 1.53. What is the ratio of the Aid flow (current US$) in Middle East & North Africa (developing only) in 2002 to that in 2008?
Provide a short and direct response. 0.34. What is the ratio of the Aid flow (current US$) in Namibia in 2002 to that in 2008?
Offer a very short reply. 4.15. What is the ratio of the Aid flow (current US$) of Nepal in 2002 to that in 2008?
Your answer should be compact. 1.42. What is the ratio of the Aid flow (current US$) in Middle East & North Africa (developing only) in 2003 to that in 2004?
Keep it short and to the point. 0.73. What is the ratio of the Aid flow (current US$) in Nepal in 2003 to that in 2004?
Your answer should be compact. 1.15. What is the ratio of the Aid flow (current US$) of Senegal in 2003 to that in 2004?
Offer a terse response. 0.03. What is the ratio of the Aid flow (current US$) in Middle East & North Africa (developing only) in 2003 to that in 2005?
Offer a terse response. 0.86. What is the ratio of the Aid flow (current US$) in Namibia in 2003 to that in 2005?
Your answer should be compact. 1.84. What is the ratio of the Aid flow (current US$) in Nepal in 2003 to that in 2005?
Ensure brevity in your answer.  1.05. What is the ratio of the Aid flow (current US$) in Senegal in 2003 to that in 2005?
Make the answer very short. 0.55. What is the ratio of the Aid flow (current US$) of Middle East & North Africa (developing only) in 2003 to that in 2006?
Offer a terse response. 0.16. What is the ratio of the Aid flow (current US$) of Namibia in 2003 to that in 2006?
Offer a terse response. 1.1. What is the ratio of the Aid flow (current US$) of Nepal in 2003 to that in 2006?
Your response must be concise. 0.57. What is the ratio of the Aid flow (current US$) in Middle East & North Africa (developing only) in 2003 to that in 2007?
Give a very brief answer. 0.5. What is the ratio of the Aid flow (current US$) of Namibia in 2003 to that in 2007?
Your response must be concise. 2.39. What is the ratio of the Aid flow (current US$) of Senegal in 2003 to that in 2007?
Offer a terse response. 1.63. What is the ratio of the Aid flow (current US$) in Middle East & North Africa (developing only) in 2003 to that in 2008?
Offer a terse response. 0.44. What is the ratio of the Aid flow (current US$) of Namibia in 2003 to that in 2008?
Your answer should be very brief. 4.33. What is the ratio of the Aid flow (current US$) of Nepal in 2003 to that in 2008?
Give a very brief answer. 0.48. What is the ratio of the Aid flow (current US$) of Senegal in 2003 to that in 2008?
Provide a succinct answer. 1.07. What is the ratio of the Aid flow (current US$) of Middle East & North Africa (developing only) in 2004 to that in 2005?
Make the answer very short. 1.18. What is the ratio of the Aid flow (current US$) of Namibia in 2004 to that in 2005?
Ensure brevity in your answer.  1.84. What is the ratio of the Aid flow (current US$) in Senegal in 2004 to that in 2005?
Your answer should be compact. 15.95. What is the ratio of the Aid flow (current US$) in Middle East & North Africa (developing only) in 2004 to that in 2006?
Keep it short and to the point. 0.22. What is the ratio of the Aid flow (current US$) of Namibia in 2004 to that in 2006?
Offer a very short reply. 1.09. What is the ratio of the Aid flow (current US$) in Nepal in 2004 to that in 2006?
Provide a short and direct response. 0.5. What is the ratio of the Aid flow (current US$) of Senegal in 2004 to that in 2006?
Make the answer very short. 14.4. What is the ratio of the Aid flow (current US$) in Middle East & North Africa (developing only) in 2004 to that in 2007?
Provide a short and direct response. 0.69. What is the ratio of the Aid flow (current US$) of Namibia in 2004 to that in 2007?
Ensure brevity in your answer.  2.39. What is the ratio of the Aid flow (current US$) in Middle East & North Africa (developing only) in 2004 to that in 2008?
Keep it short and to the point. 0.6. What is the ratio of the Aid flow (current US$) in Namibia in 2004 to that in 2008?
Offer a terse response. 4.33. What is the ratio of the Aid flow (current US$) of Nepal in 2004 to that in 2008?
Your response must be concise. 0.41. What is the ratio of the Aid flow (current US$) of Senegal in 2004 to that in 2008?
Make the answer very short. 30.79. What is the ratio of the Aid flow (current US$) of Middle East & North Africa (developing only) in 2005 to that in 2006?
Your answer should be compact. 0.19. What is the ratio of the Aid flow (current US$) in Namibia in 2005 to that in 2006?
Ensure brevity in your answer.  0.6. What is the ratio of the Aid flow (current US$) of Nepal in 2005 to that in 2006?
Make the answer very short. 0.55. What is the ratio of the Aid flow (current US$) of Senegal in 2005 to that in 2006?
Offer a very short reply. 0.9. What is the ratio of the Aid flow (current US$) of Middle East & North Africa (developing only) in 2005 to that in 2007?
Offer a terse response. 0.59. What is the ratio of the Aid flow (current US$) of Namibia in 2005 to that in 2007?
Provide a succinct answer. 1.3. What is the ratio of the Aid flow (current US$) in Senegal in 2005 to that in 2007?
Your answer should be compact. 2.95. What is the ratio of the Aid flow (current US$) in Middle East & North Africa (developing only) in 2005 to that in 2008?
Offer a very short reply. 0.51. What is the ratio of the Aid flow (current US$) of Namibia in 2005 to that in 2008?
Make the answer very short. 2.36. What is the ratio of the Aid flow (current US$) of Nepal in 2005 to that in 2008?
Provide a succinct answer. 0.45. What is the ratio of the Aid flow (current US$) of Senegal in 2005 to that in 2008?
Your response must be concise. 1.93. What is the ratio of the Aid flow (current US$) in Middle East & North Africa (developing only) in 2006 to that in 2007?
Your answer should be very brief. 3.13. What is the ratio of the Aid flow (current US$) of Namibia in 2006 to that in 2007?
Offer a terse response. 2.18. What is the ratio of the Aid flow (current US$) in Senegal in 2006 to that in 2007?
Provide a short and direct response. 3.26. What is the ratio of the Aid flow (current US$) of Middle East & North Africa (developing only) in 2006 to that in 2008?
Provide a short and direct response. 2.74. What is the ratio of the Aid flow (current US$) in Namibia in 2006 to that in 2008?
Offer a very short reply. 3.95. What is the ratio of the Aid flow (current US$) of Nepal in 2006 to that in 2008?
Your answer should be very brief. 0.83. What is the ratio of the Aid flow (current US$) in Senegal in 2006 to that in 2008?
Ensure brevity in your answer.  2.14. What is the ratio of the Aid flow (current US$) in Middle East & North Africa (developing only) in 2007 to that in 2008?
Provide a short and direct response. 0.87. What is the ratio of the Aid flow (current US$) of Namibia in 2007 to that in 2008?
Offer a terse response. 1.81. What is the ratio of the Aid flow (current US$) of Senegal in 2007 to that in 2008?
Offer a terse response. 0.66. What is the difference between the highest and the second highest Aid flow (current US$) in Middle East & North Africa (developing only)?
Offer a very short reply. 2.25e+08. What is the difference between the highest and the second highest Aid flow (current US$) in Nepal?
Keep it short and to the point. 1.00e+07. What is the difference between the highest and the second highest Aid flow (current US$) of Senegal?
Provide a short and direct response. 8.31e+06. What is the difference between the highest and the lowest Aid flow (current US$) of Middle East & North Africa (developing only)?
Your response must be concise. 3.17e+08. What is the difference between the highest and the lowest Aid flow (current US$) in Namibia?
Ensure brevity in your answer.  7.57e+06. What is the difference between the highest and the lowest Aid flow (current US$) in Nepal?
Offer a terse response. 1.36e+07. What is the difference between the highest and the lowest Aid flow (current US$) of Senegal?
Make the answer very short. 8.84e+06. 